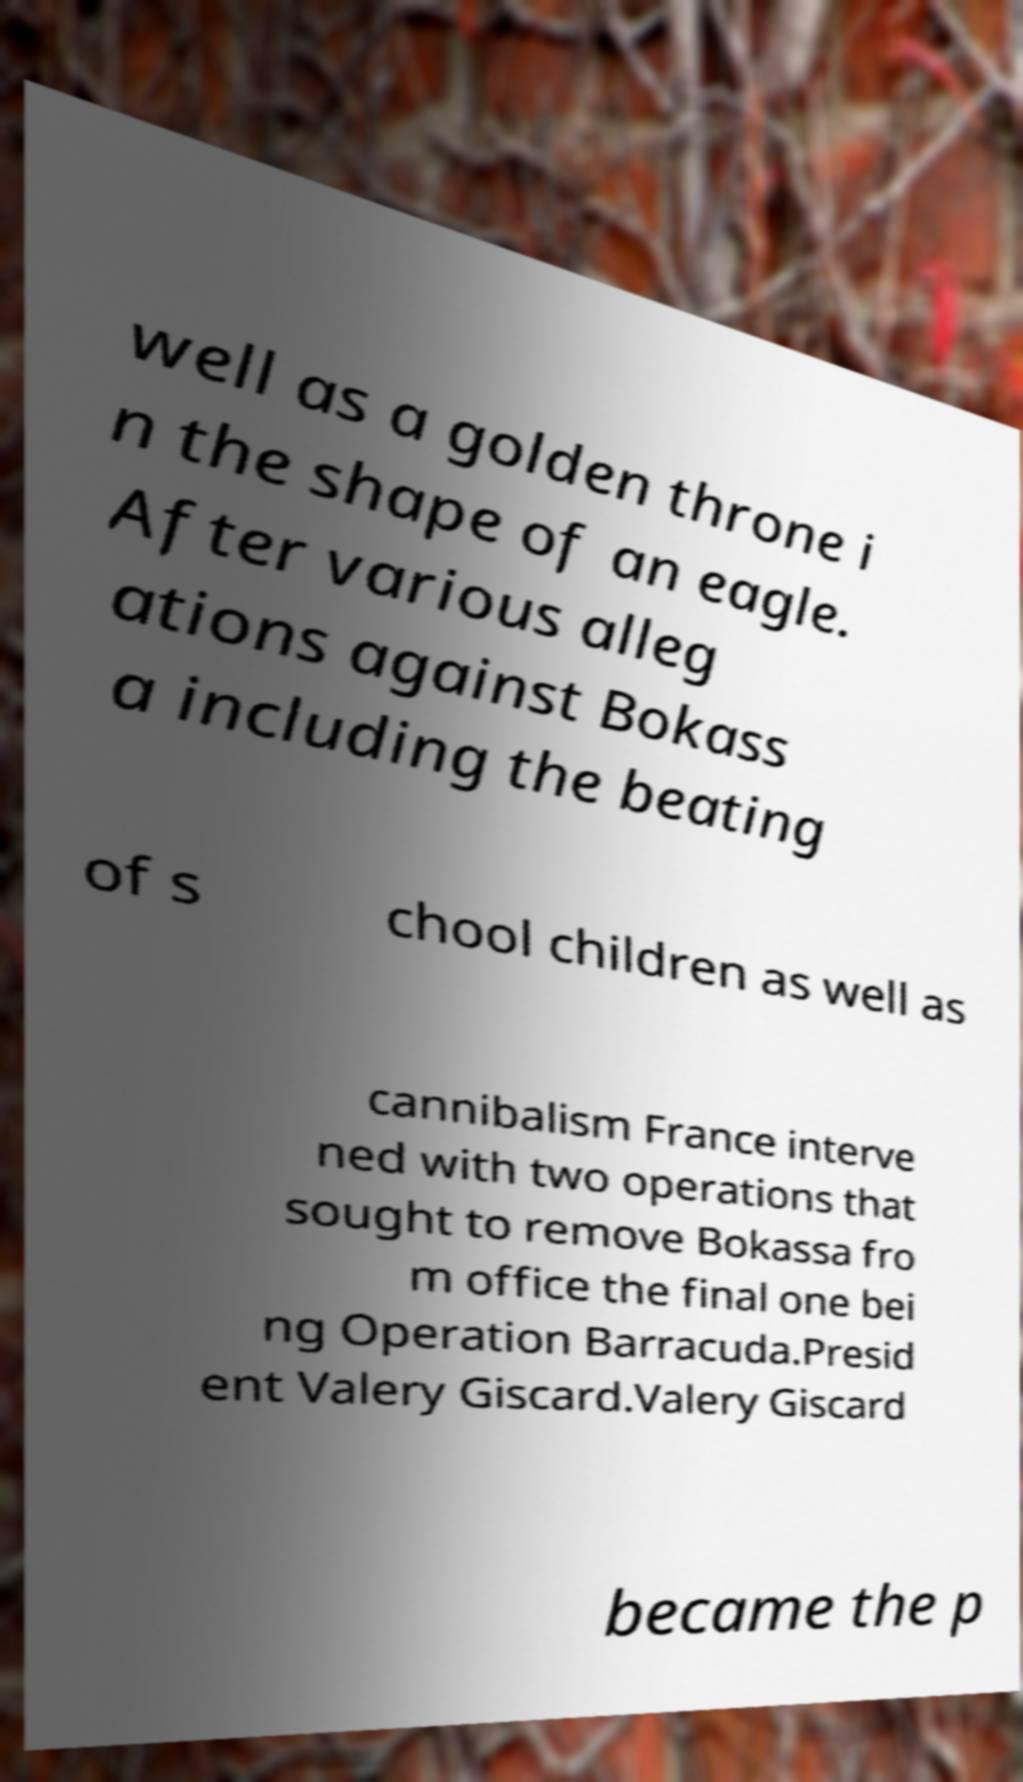Please identify and transcribe the text found in this image. well as a golden throne i n the shape of an eagle. After various alleg ations against Bokass a including the beating of s chool children as well as cannibalism France interve ned with two operations that sought to remove Bokassa fro m office the final one bei ng Operation Barracuda.Presid ent Valery Giscard.Valery Giscard became the p 